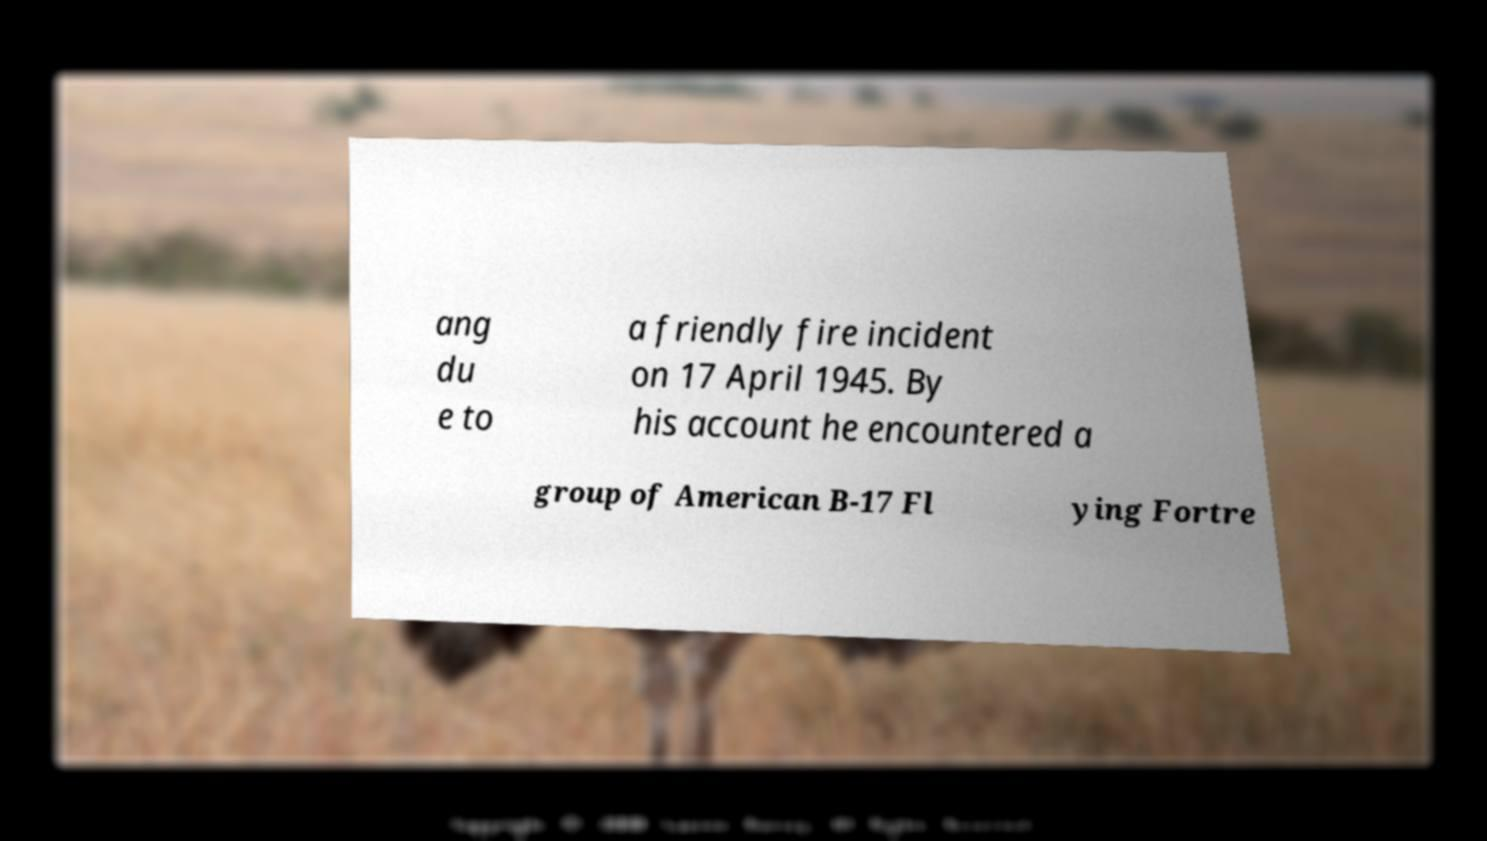Please identify and transcribe the text found in this image. ang du e to a friendly fire incident on 17 April 1945. By his account he encountered a group of American B-17 Fl ying Fortre 